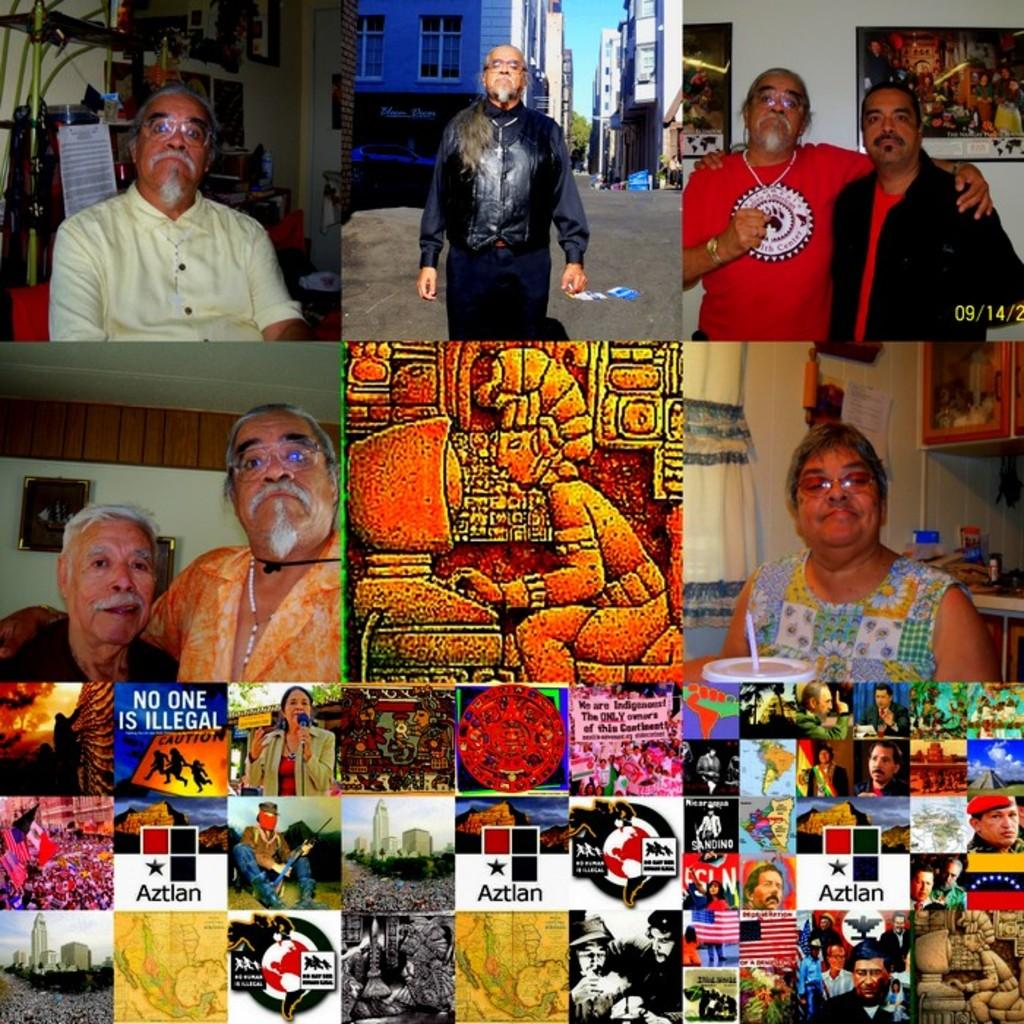What is the format of the image? The image is a collage of nine images. How many images are included in the collage? There are nine images in the collage. Can you describe the content of some of the images? Some of the images contain humans, while one image contains a carving on a wall, and some images contain logos. What type of locket can be seen hanging from the neck of the person in the image? There is no person wearing a locket in the image; the collage contains various images, but none of them show a person with a locket. 